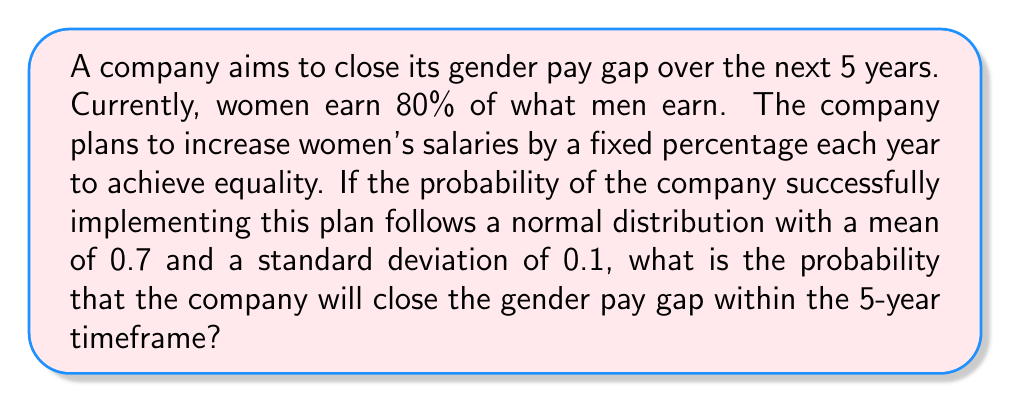Solve this math problem. Let's approach this step-by-step:

1) First, we need to calculate the annual increase rate required to close the gap in 5 years:
   Let $x$ be the annual increase rate.
   $$(1+x)^5 = \frac{1}{0.8}$$
   $$x = (\frac{1}{0.8})^{\frac{1}{5}} - 1 \approx 0.0456 \text{ or } 4.56\% \text{ per year}$$

2) Now, we're told that the probability of success follows a normal distribution with:
   $\mu = 0.7$ (mean)
   $\sigma = 0.1$ (standard deviation)

3) We want to find the probability that the company will succeed, which means the probability that the actual outcome is greater than or equal to the required 4.56% annual increase.

4) To do this, we need to calculate the z-score for the required increase rate:
   $$z = \frac{x - \mu}{\sigma} = \frac{0.0456 - 0.7}{0.1} = -6.544$$

5) The probability we're looking for is the area to the right of this z-score on the standard normal distribution curve.

6) We can find this using the complementary cumulative distribution function (CCDF) of the standard normal distribution:
   $$P(Z > -6.544) = 1 - P(Z \leq -6.544) = 1 - \Phi(-6.544)$$

7) Using a standard normal table or calculator:
   $$1 - \Phi(-6.544) \approx 1$$
Answer: $\approx 1$ or $>0.9999$ 